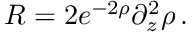<formula> <loc_0><loc_0><loc_500><loc_500>R = 2 e ^ { - 2 \rho } \partial _ { z } ^ { 2 } \rho \, .</formula> 